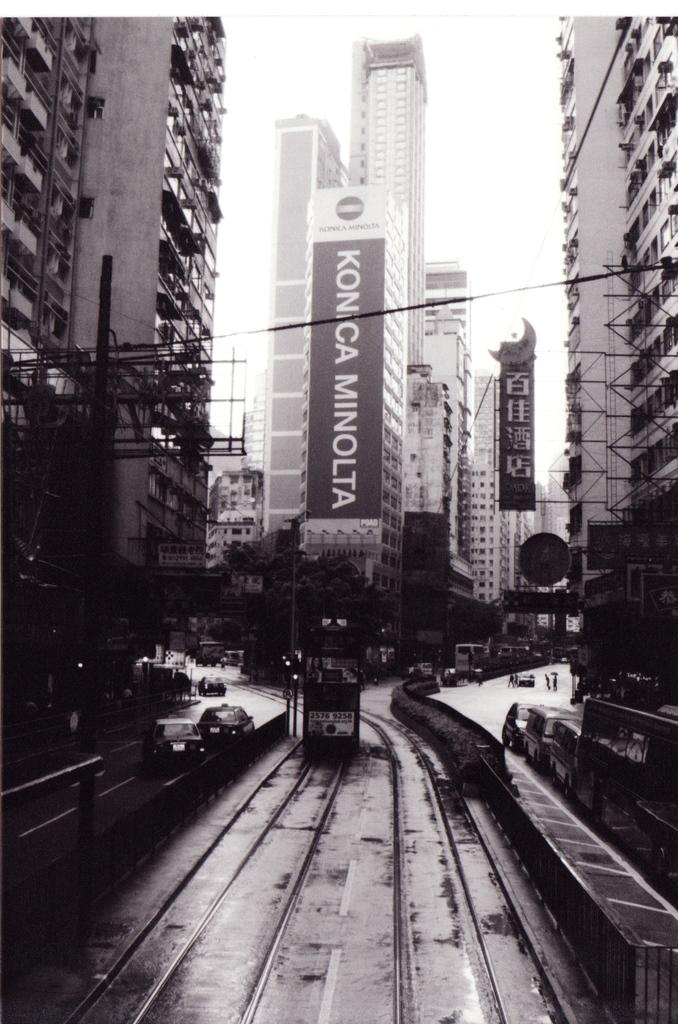<image>
Render a clear and concise summary of the photo. A sign for Konica Minolta is on a tall building in a black and white photo. 